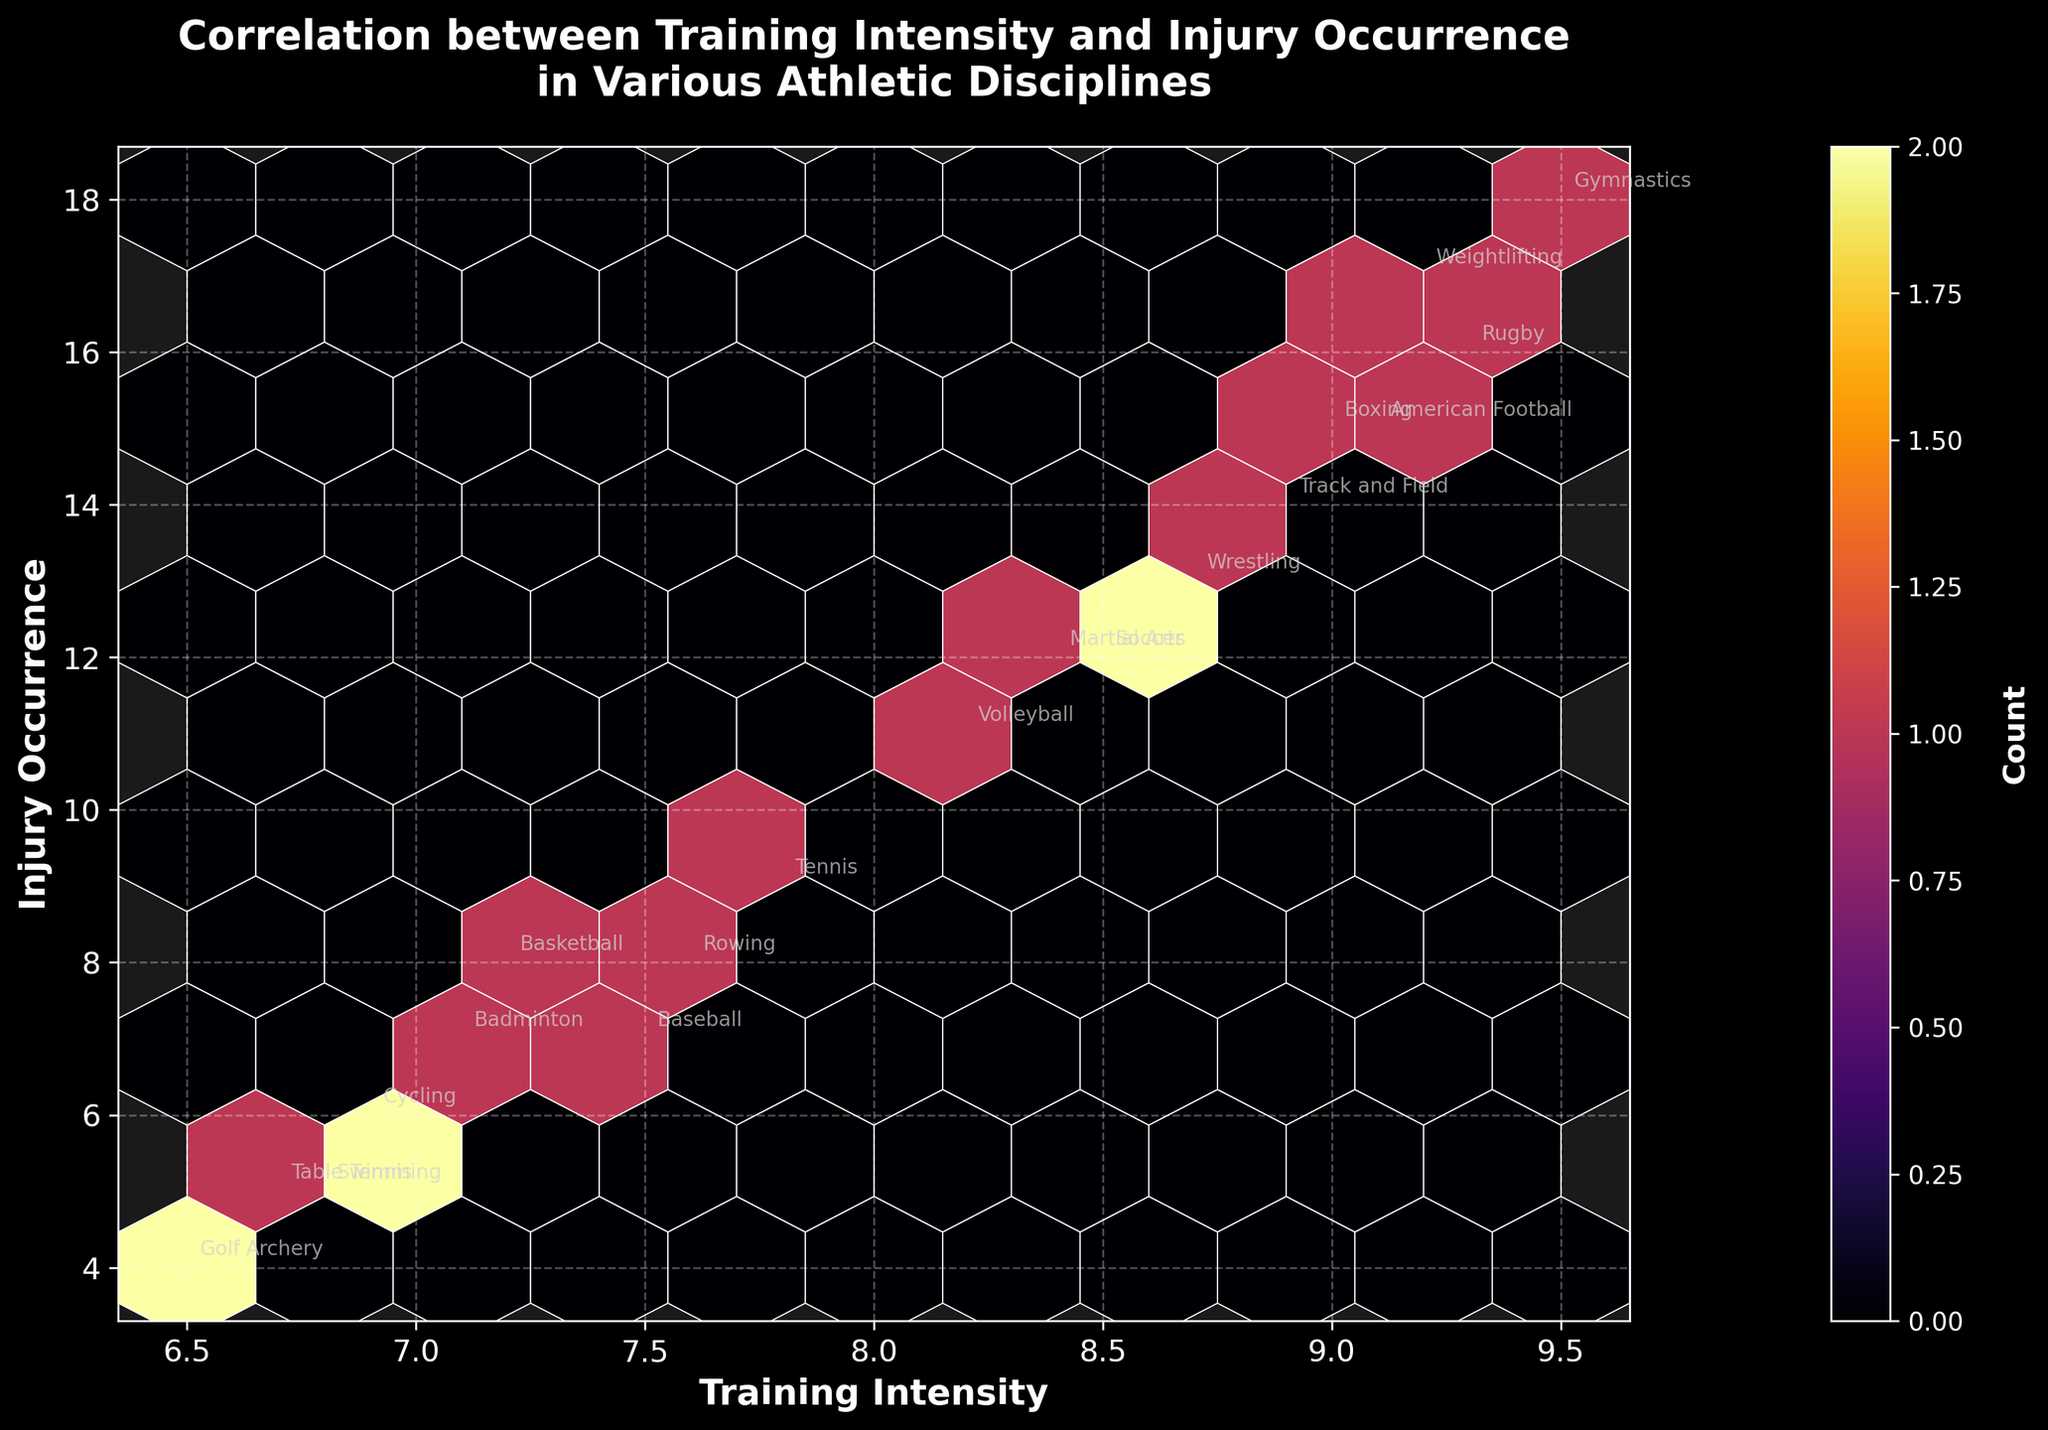What is the title of the figure? The title of the figure is displayed at the top of the hexbin plot. Reading from the figure, the title is "Correlation between Training Intensity and Injury Occurrence in Various Athletic Disciplines."
Answer: Correlation between Training Intensity and Injury Occurrence in Various Athletic Disciplines What are the x and y axes labels? By looking at the labels along the x-axis and y-axis, you can see that the x-axis is labeled "Training Intensity" and the y-axis is labeled "Injury Occurrence."
Answer: Training Intensity and Injury Occurrence Which sport has the highest training intensity? To determine this, look for the point furthest to the right on the x-axis, which represents the highest training intensity. According to the annotations, this sport is Gymnastics.
Answer: Gymnastics How many sports have a training intensity greater than 9? Count the sports annotated where their x-axis value (Training Intensity) is greater than 9. They are American Football, Gymnastics, Rugby, Boxing, and Weightlifting, which results in a total of 5 sports.
Answer: 5 Is there a correlation between training intensity and injury occurrence? To determine this, observe if there is a pattern where higher training intensity is associated with higher injury occurrence. The plot shows a general upward trend and concentration of hexagons, indicating a positive correlation.
Answer: Yes Which sport has the lowest injury occurrence? Look for the point closest to the bottom of the y-axis, which represents the lowest injury occurrence. According to the annotations, this sport is Archery.
Answer: Archery Among sports with a training intensity around 8.5, which one has the highest injury occurrence? Locate the point on the x-axis around 8.5 and find the sport with the highest y-axis value among them. Wrestling has a training intensity close to 8.5 and the highest injury occurrence compared to others nearby.
Answer: Wrestling What is the color used for the highest density of data points? The color corresponding to the highest density can be found by looking at the darkest hexagons on the plot and matching it with the color bar. The darkest color used in the 'inferno' colormap is close to dark red or black.
Answer: Dark red or black Comparing Baseball and Cycling, which sport has a higher training intensity and which one has a higher injury occurrence? Baseball has a training intensity of 7.5 and an injury occurrence of 7, while Cycling has a training intensity of 6.9 and an injury occurrence of 6. Therefore, Baseball has both higher training intensity and injury occurrence.
Answer: Baseball in both What might be a reason for an athlete to carefully manage their training intensity based on this plot? The plot suggests that higher training intensity is correlated with higher injury occurrence. Hence, athletes should manage their training intensity to avoid injuries, as indicated by the upward trend in the data points.
Answer: To avoid higher injury occurrence 